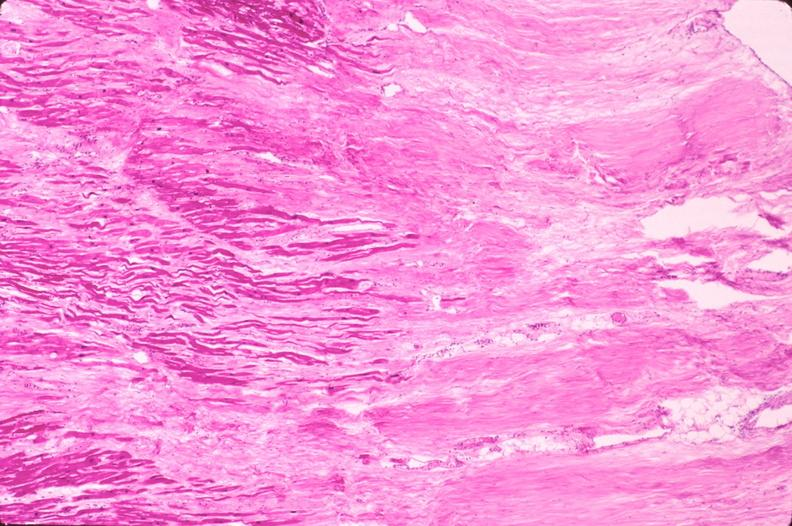does typical tuberculous exudate show heart, myocardial infarction free wall, 6 days old, in a patient with diabetes mellitus and hypertension?
Answer the question using a single word or phrase. No 